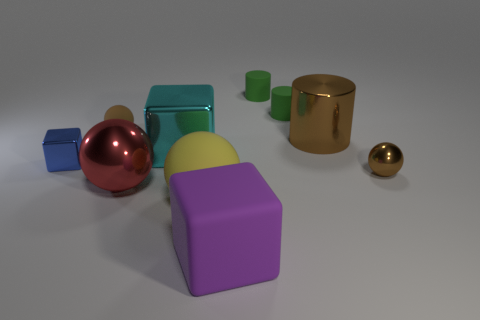Subtract all cyan cylinders. How many brown balls are left? 2 Subtract all tiny matte spheres. How many spheres are left? 3 Subtract all yellow balls. How many balls are left? 3 Subtract 1 cylinders. How many cylinders are left? 2 Subtract all balls. How many objects are left? 6 Subtract all purple spheres. Subtract all brown cubes. How many spheres are left? 4 Subtract all big purple matte cubes. Subtract all large purple rubber cubes. How many objects are left? 8 Add 8 small brown matte things. How many small brown matte things are left? 9 Add 1 big green rubber spheres. How many big green rubber spheres exist? 1 Subtract 0 purple cylinders. How many objects are left? 10 